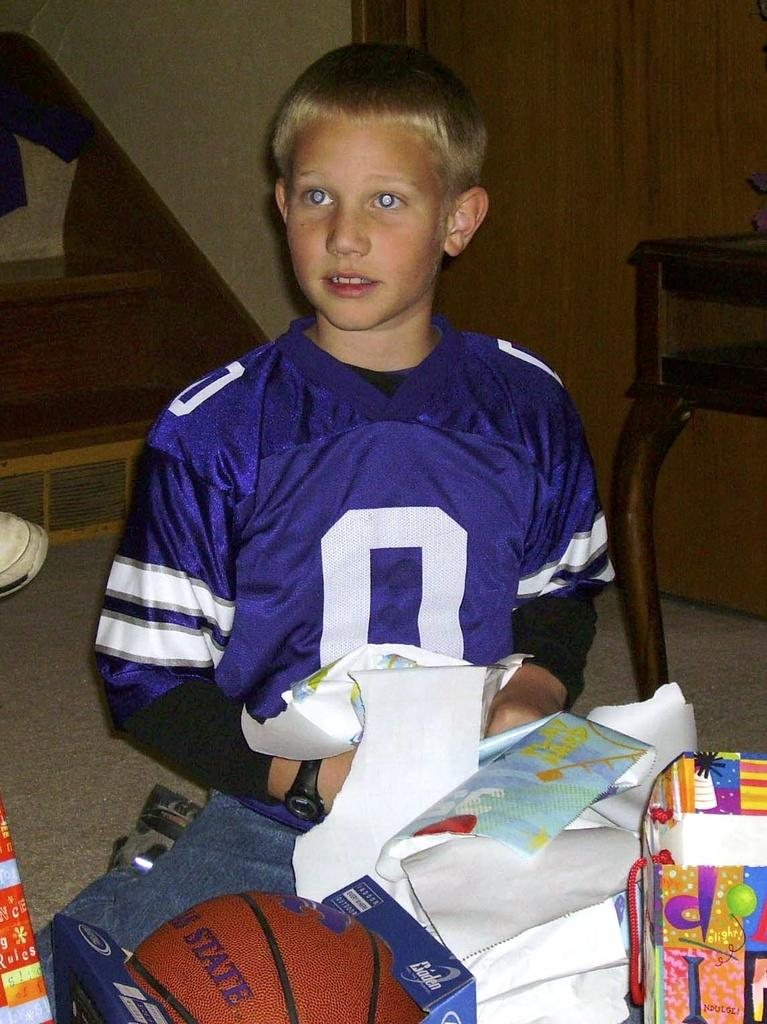<image>
Offer a succinct explanation of the picture presented. A young boy in a purple jersey with the number 0 on it opens gifts. 